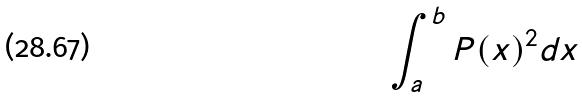Convert formula to latex. <formula><loc_0><loc_0><loc_500><loc_500>\int _ { a } ^ { b } P ( x ) ^ { 2 } d x</formula> 